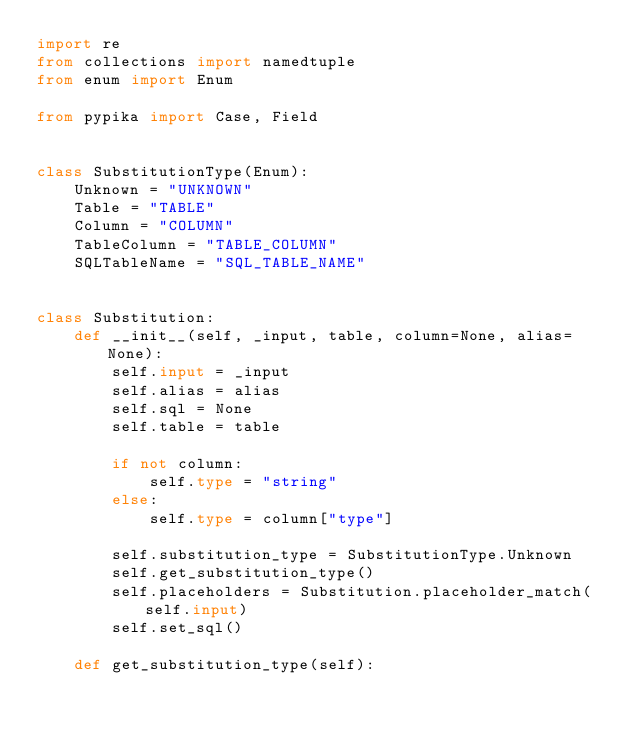<code> <loc_0><loc_0><loc_500><loc_500><_Python_>import re
from collections import namedtuple
from enum import Enum

from pypika import Case, Field


class SubstitutionType(Enum):
    Unknown = "UNKNOWN"
    Table = "TABLE"
    Column = "COLUMN"
    TableColumn = "TABLE_COLUMN"
    SQLTableName = "SQL_TABLE_NAME"


class Substitution:
    def __init__(self, _input, table, column=None, alias=None):
        self.input = _input
        self.alias = alias
        self.sql = None
        self.table = table

        if not column:
            self.type = "string"
        else:
            self.type = column["type"]

        self.substitution_type = SubstitutionType.Unknown
        self.get_substitution_type()
        self.placeholders = Substitution.placeholder_match(self.input)
        self.set_sql()

    def get_substitution_type(self):</code> 